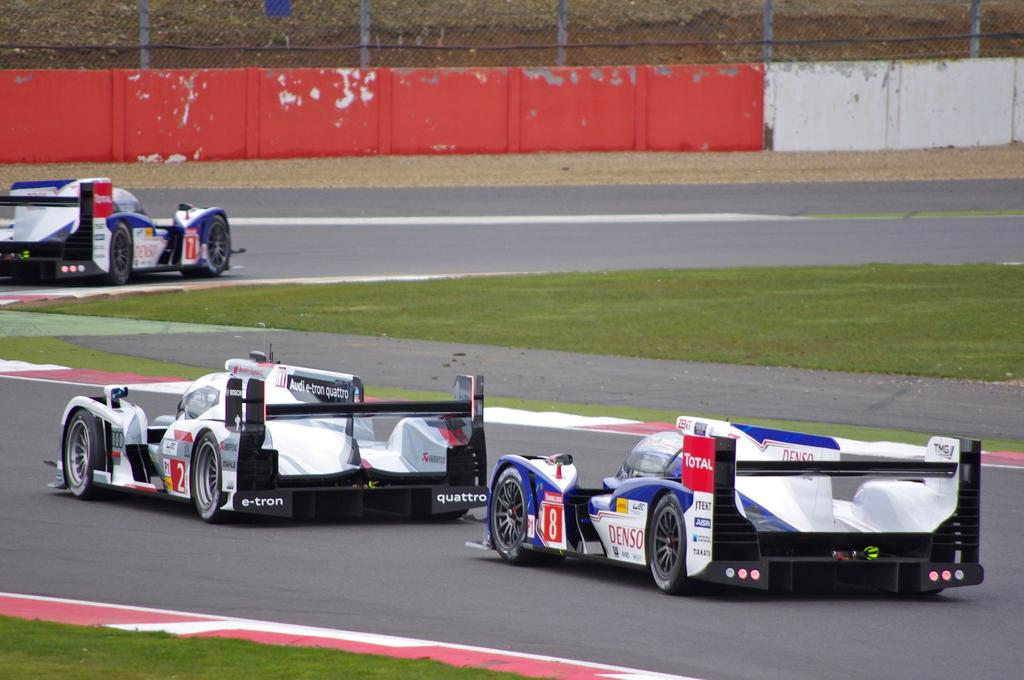What is the main feature of the image? There is a road in the image. What is happening on the road? Three vehicles are moving towards the right on the road. What is in the center of the road? There is grass in the center of the road. What can be seen at the top of the image? There is a wall with a fence on the top of the image. Can you hear the bee buzzing in the image? There is no bee present in the image, so it is not possible to hear it buzzing. 